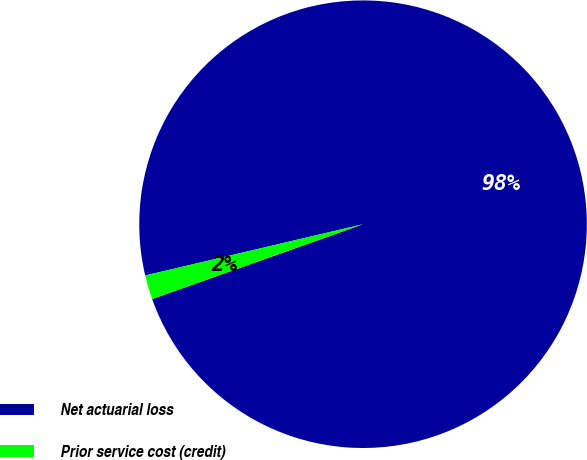Convert chart to OTSL. <chart><loc_0><loc_0><loc_500><loc_500><pie_chart><fcel>Net actuarial loss<fcel>Prior service cost (credit)<nl><fcel>98.25%<fcel>1.75%<nl></chart> 